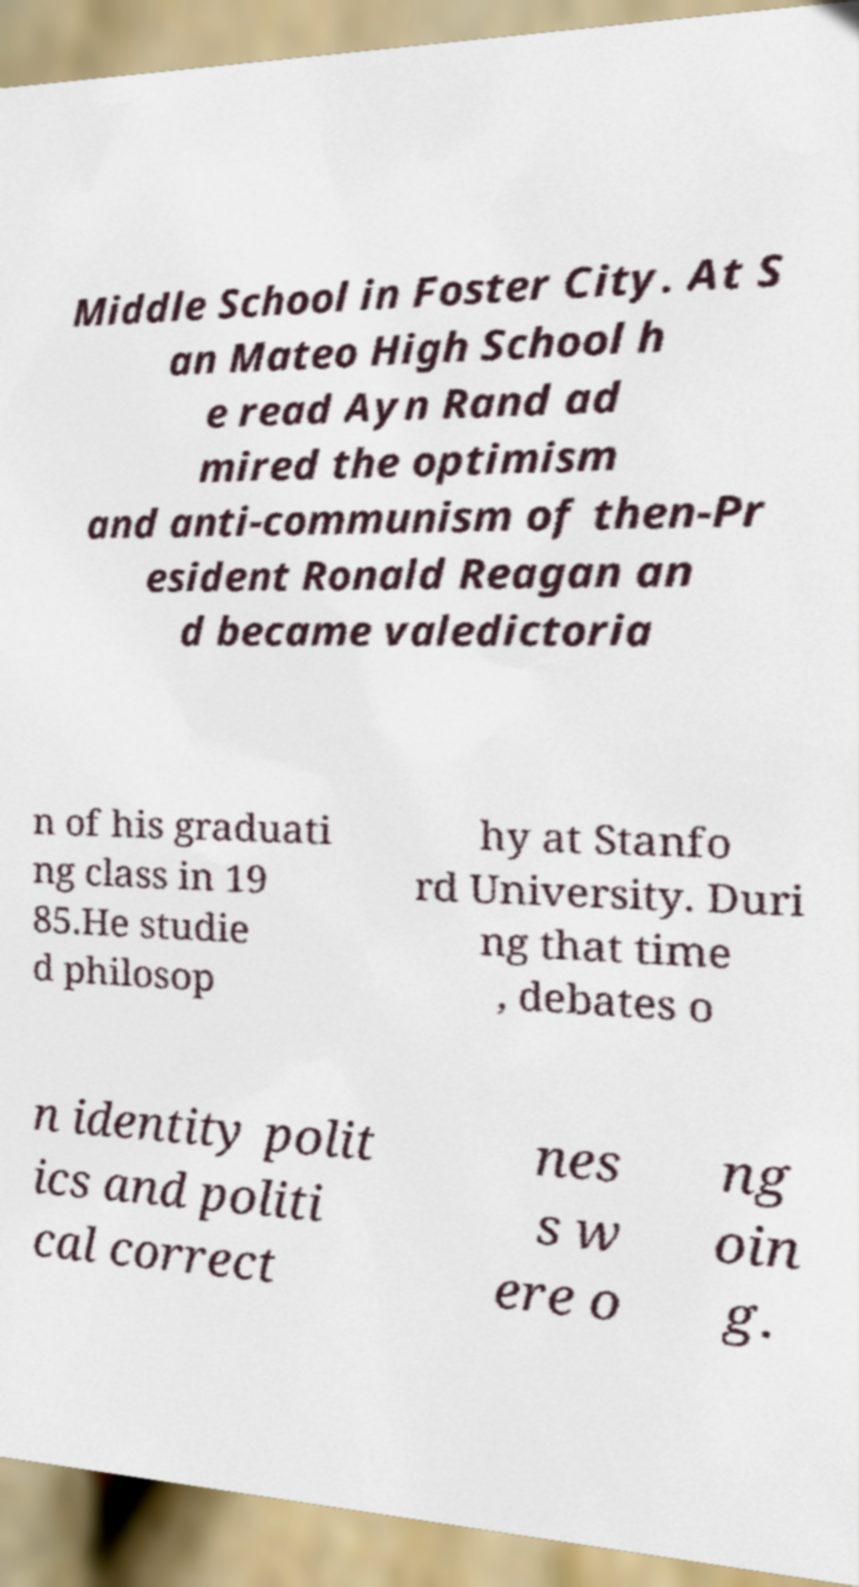There's text embedded in this image that I need extracted. Can you transcribe it verbatim? Middle School in Foster City. At S an Mateo High School h e read Ayn Rand ad mired the optimism and anti-communism of then-Pr esident Ronald Reagan an d became valedictoria n of his graduati ng class in 19 85.He studie d philosop hy at Stanfo rd University. Duri ng that time , debates o n identity polit ics and politi cal correct nes s w ere o ng oin g. 